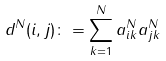Convert formula to latex. <formula><loc_0><loc_0><loc_500><loc_500>& d ^ { N } ( i , j ) \colon = \sum _ { k = 1 } ^ { N } a _ { i k } ^ { N } a _ { j k } ^ { N }</formula> 